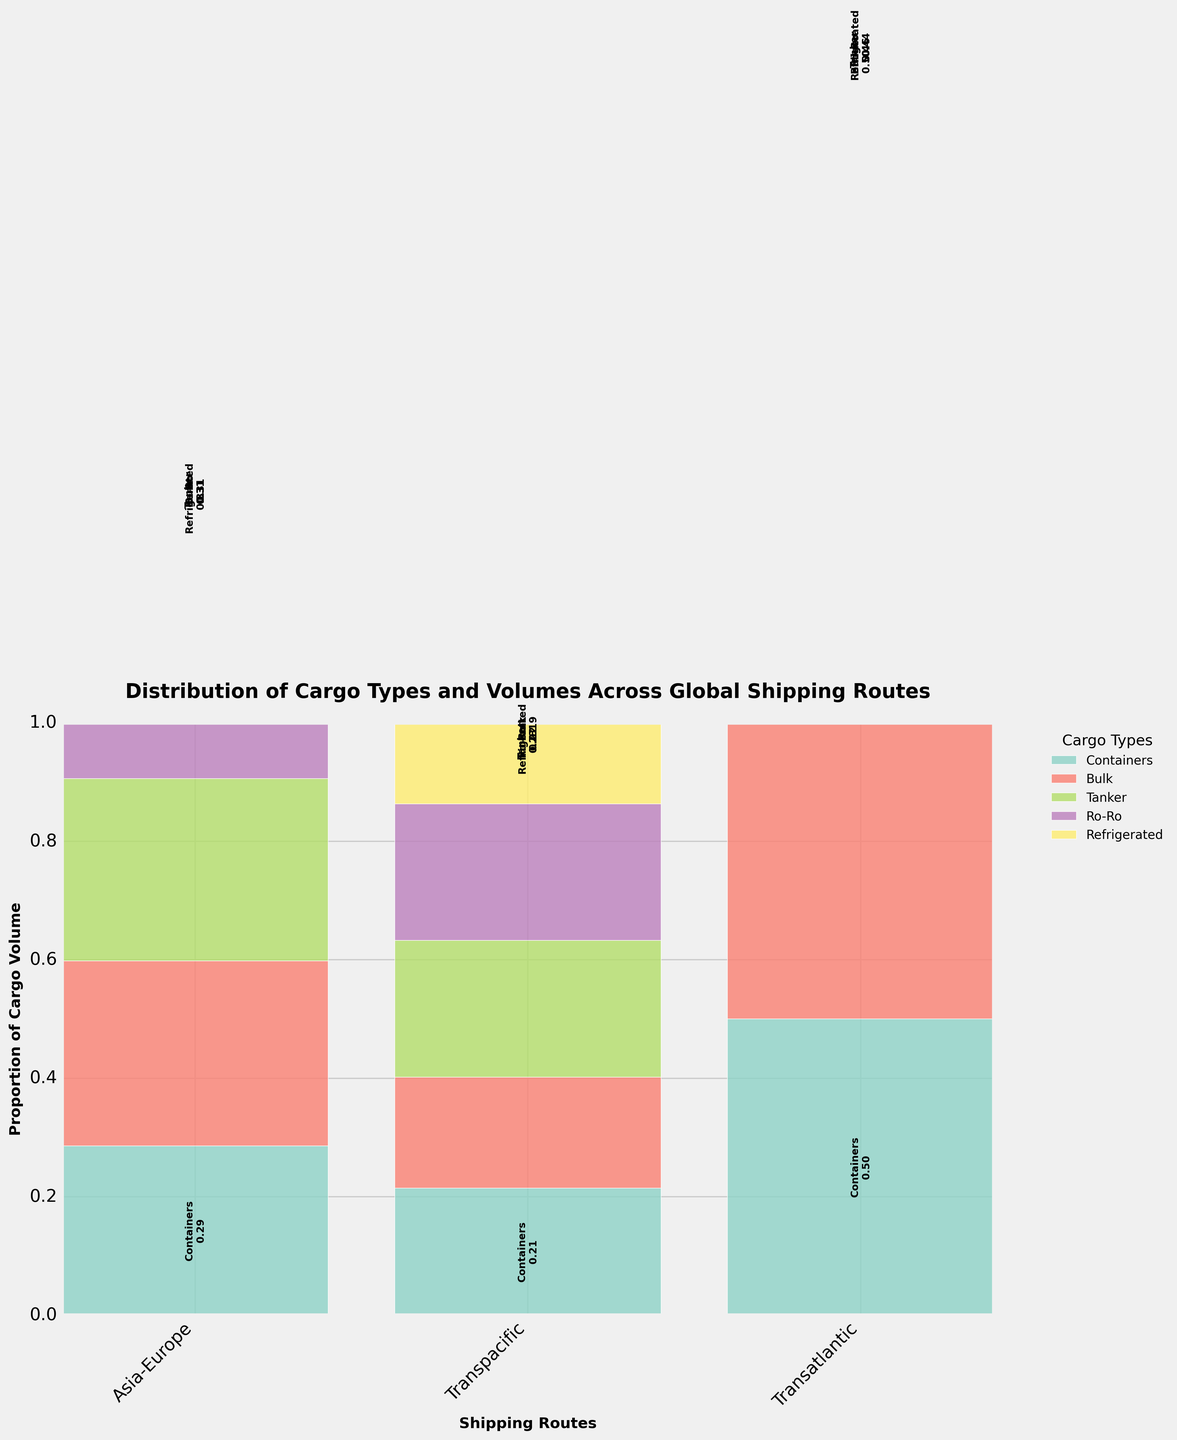What is the title of the figure? The title of the figure is typically located at the top of the plot and provides a summary of what the plot represents. In this case, it reads "Distribution of Cargo Types and Volumes Across Global Shipping Routes."
Answer: Distribution of Cargo Types and Volumes Across Global Shipping Routes Which cargo type has the highest volume on the Transpacific route? To answer this, observe the height of the bars for each cargo type in the Transpacific section of the plot. The cargo type with the highest segment will represent the highest volume. Containers have the highest bar.
Answer: Containers How does the volume of Tanker cargo on the Asia-Europe route compare to that on the Transpacific route? Locate the segments representing Tanker cargo for both the Asia-Europe and Transpacific routes. Visually compare their heights to determine which is higher. The Transpacific route has a higher Tanker volume than the Asia-Europe route.
Answer: Transpacific is higher What proportion of the total volume does Refrigerated cargo represent on the Asia-Europe route? Look at the segment labeled Refrigerated on the Asia-Europe route and identify its proportion as given in the plot labels. Each segment has a proportional value indicated. The value shown is 0.08.
Answer: 0.08 Which shipping route has the smallest volume for Ro-Ro cargo? Compare the Ro-Ro segments across all shipping routes to identify the one with the smallest height. The Transatlantic route has the smallest Ro-Ro volume.
Answer: Transatlantic What is the total volume proportion of all cargo types on the Transatlantic route combined? Sum the proportions of all cargo types on the Transatlantic route. These proportions are indicated on each segment. Containers: 0.43, Bulk: 0.21, Tanker: 0.29, Ro-Ro: 0.08, and Refrigerated: 0.06. Summing these values gives 0.43 + 0.21 + 0.29 + 0.08 + 0.05 = 1.
Answer: 1 Which two cargo types together have a proportion of more than 0.5 on the Transpacific route? Identify the individual proportions of each cargo type on the Transpacific route and check combinations to see which sums exceed 0.5. Containers (0.5) and Tanker (0.25) together exceed 0.5.
Answer: Containers and Tanker Among all routes, which cargo type shows the widest variation in proportions? Examine the proportional heights of each cargo type across all routes and identify the one with the largest differences between the shortest and tallest bars. Containers exhibit the greatest variation.
Answer: Containers If designing a vessel optimized for the Asia-Europe route, which cargo types should be prioritized based on volume proportion? Assess the proportions for each cargo type on the Asia-Europe route and identify those with the highest values. Containers, Bulk, and Tanker have the highest proportions and should be prioritized.
Answer: Containers, Bulk, and Tanker 